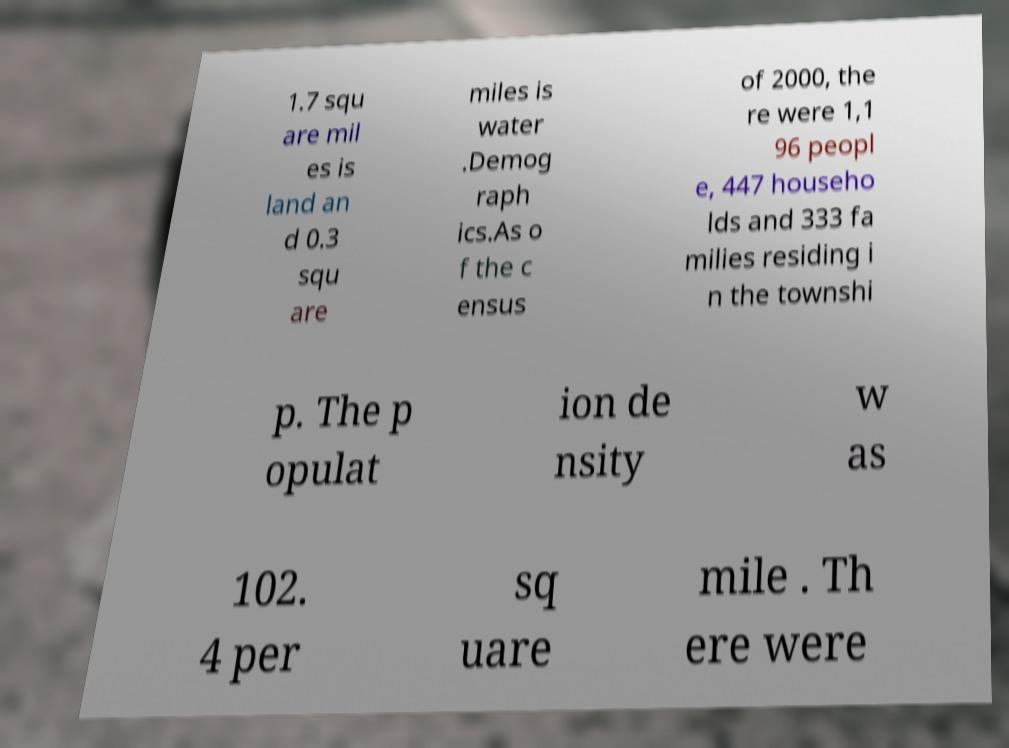Could you assist in decoding the text presented in this image and type it out clearly? 1.7 squ are mil es is land an d 0.3 squ are miles is water .Demog raph ics.As o f the c ensus of 2000, the re were 1,1 96 peopl e, 447 househo lds and 333 fa milies residing i n the townshi p. The p opulat ion de nsity w as 102. 4 per sq uare mile . Th ere were 